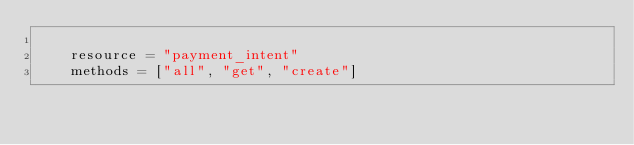Convert code to text. <code><loc_0><loc_0><loc_500><loc_500><_Python_>
    resource = "payment_intent"
    methods = ["all", "get", "create"]
</code> 